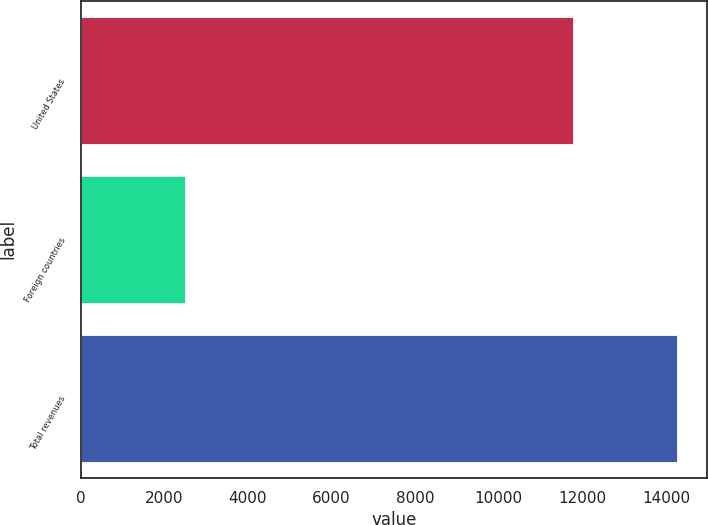Convert chart. <chart><loc_0><loc_0><loc_500><loc_500><bar_chart><fcel>United States<fcel>Foreign countries<fcel>Total revenues<nl><fcel>11782<fcel>2486<fcel>14268<nl></chart> 